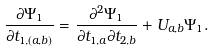<formula> <loc_0><loc_0><loc_500><loc_500>\frac { \partial \Psi _ { 1 } } { \partial t _ { 1 , ( a , b ) } } & = \frac { \partial ^ { 2 } \Psi _ { 1 } } { \partial t _ { 1 , a } \partial t _ { 2 , b } } + U _ { a , b } \Psi _ { 1 } .</formula> 